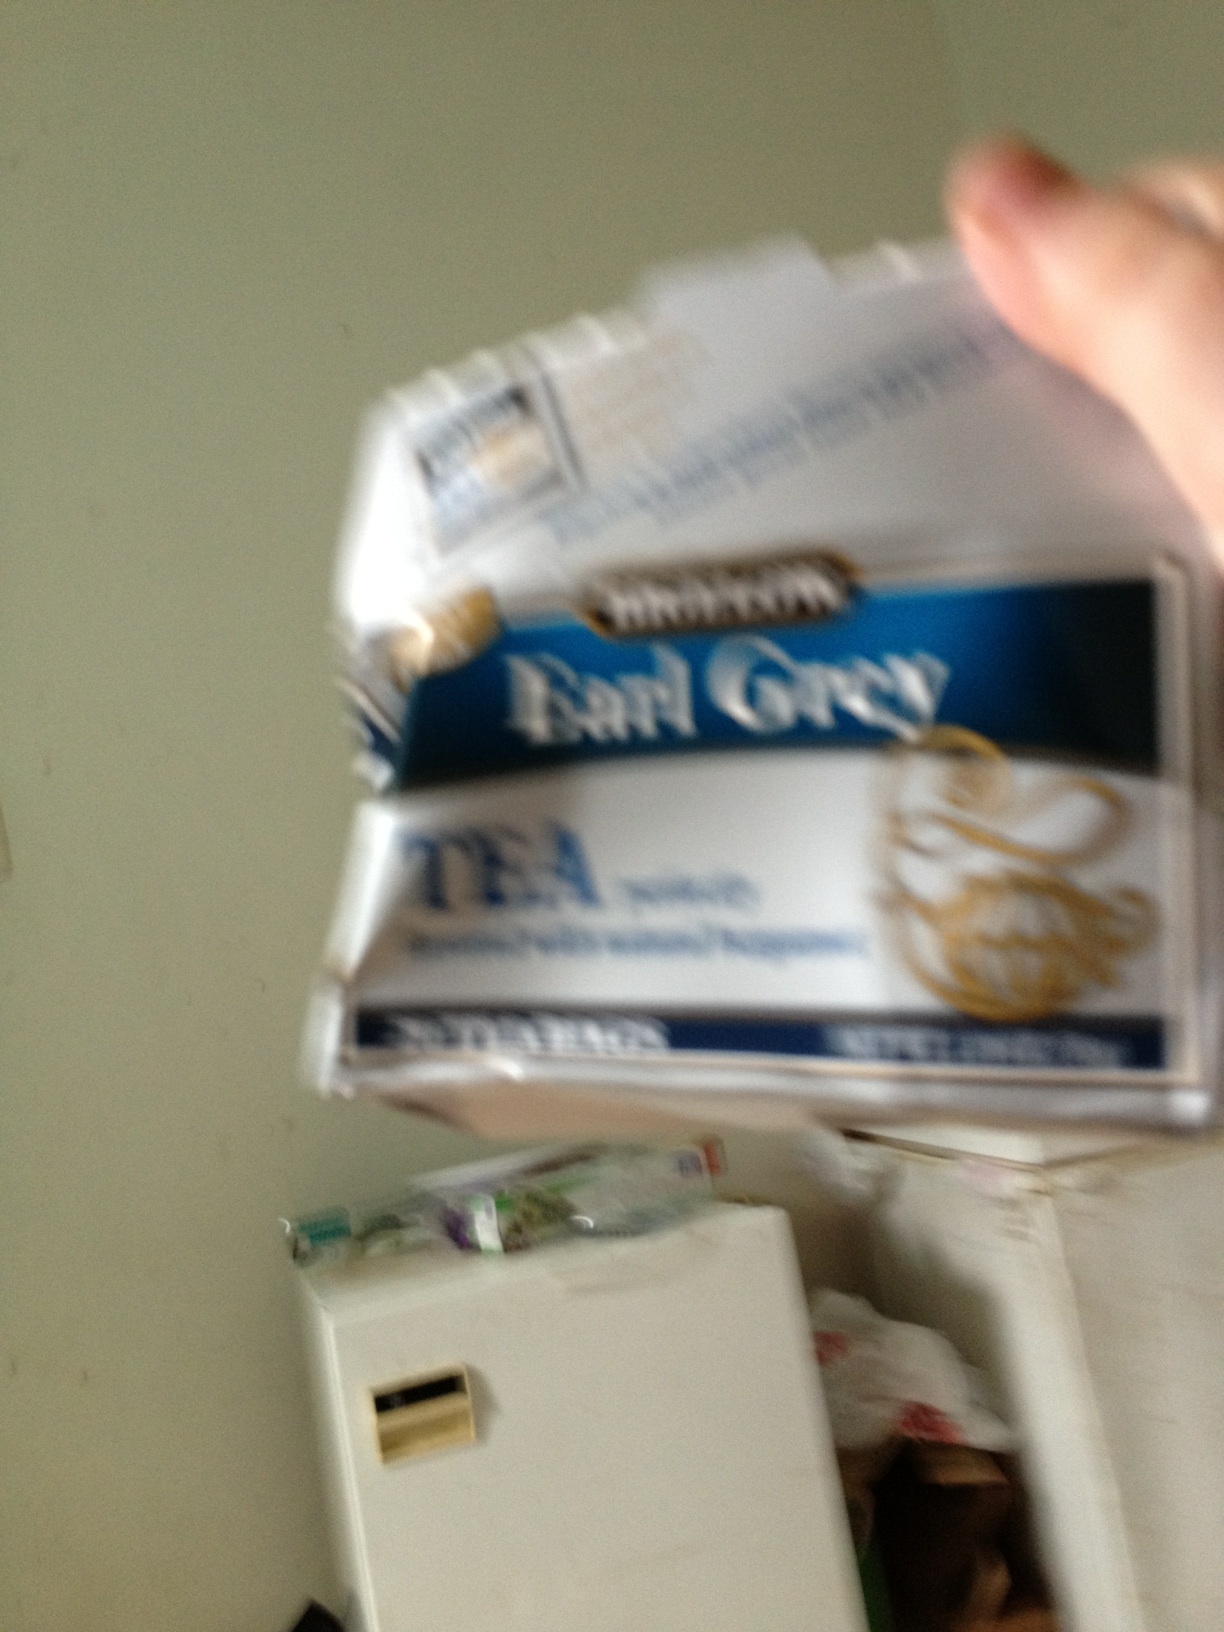What kind of tea is this? The tea in the image appears to be Earl Grey, which is easily identifiable by the distinctive blue label on the packaging that typically signifies this popular variety. Earl Grey tea is known for its unique flavor, which is derived from the oil of bergamot, a type of orange. This tea is a classic choice and enjoyed by many for its refreshing taste and aroma. 